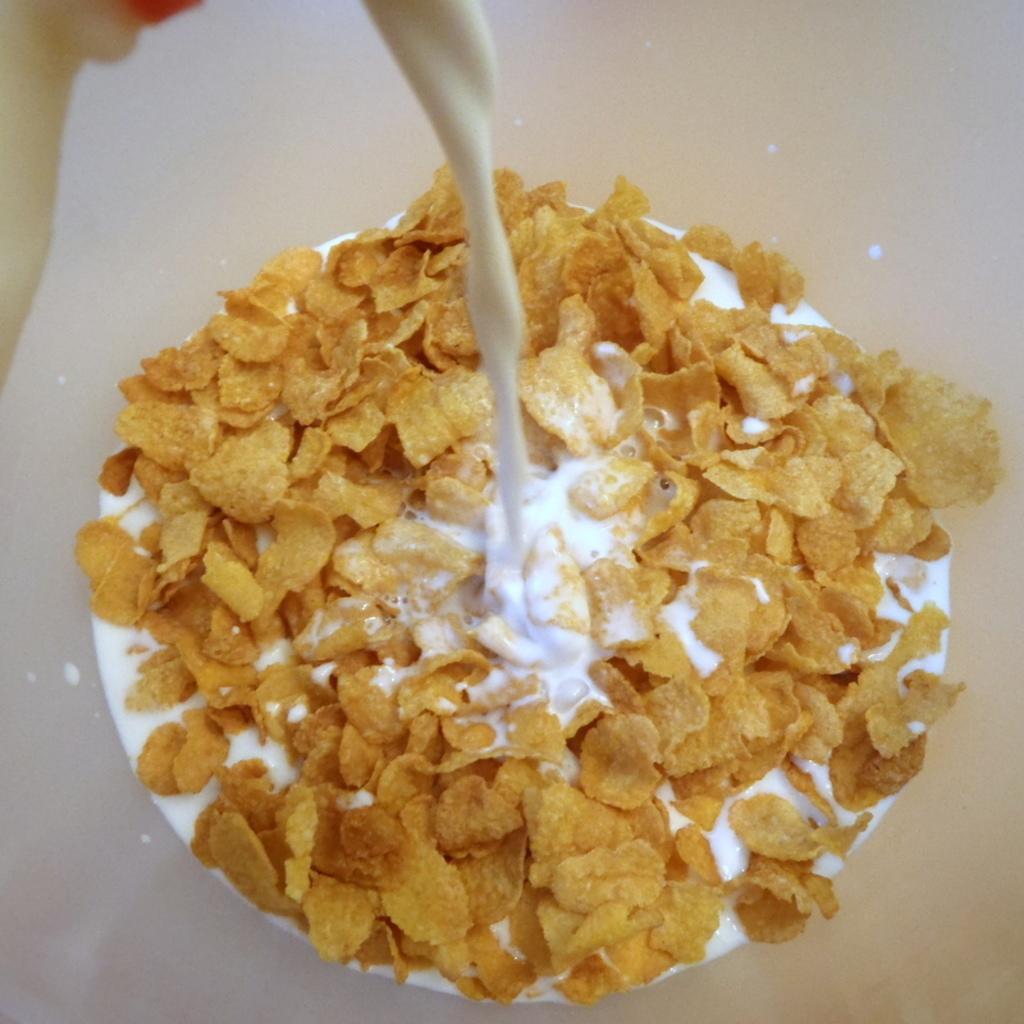What is the main object in the image that contains food? There is food in an object that looks like a bowl. What type of liquid is present in the image? There is milk visible in the image. Is there a bath scene in the image? No, there is no bath scene in the image. What type of emotion is being expressed by the food in the image? The food in the image does not express emotions, as it is an inanimate object. 